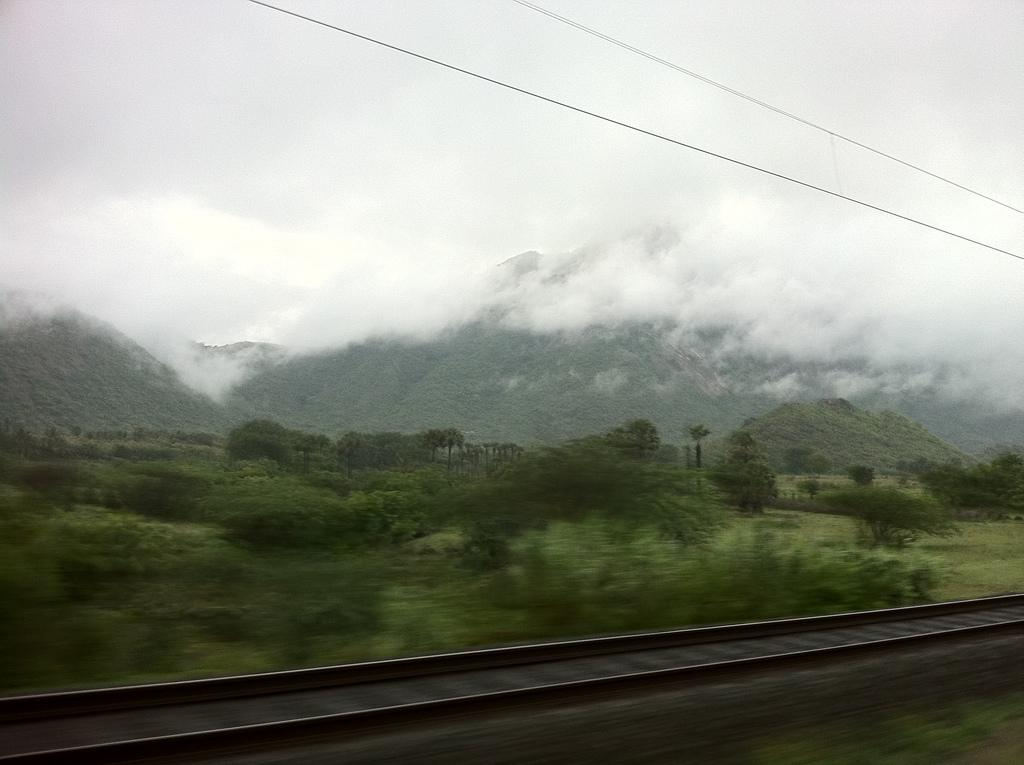What is located at the bottom of the image? There are railway tracks at the bottom of the image. What can be seen in the middle of the image? There are trees in the middle of the image. What is visible at the top of the image? The sky is visible at the top of the image. What color is the blood on the railway tracks in the image? There is no blood present on the railway tracks in the image. What type of beam is holding up the trees in the image? There are no beams visible in the image; the trees are standing on their own. 